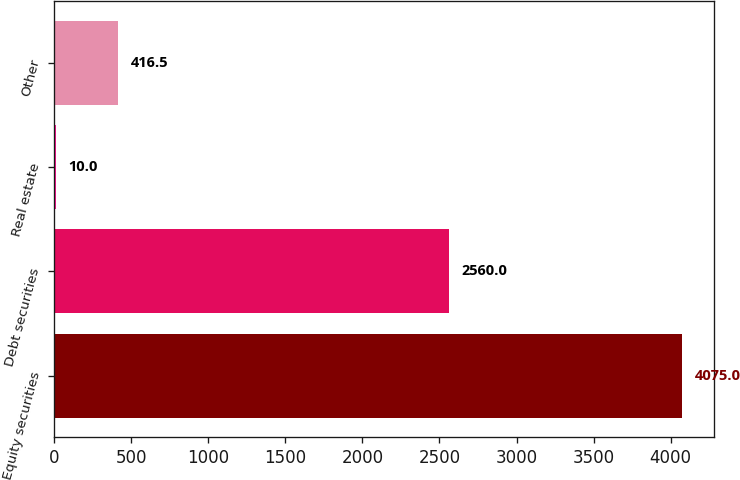Convert chart to OTSL. <chart><loc_0><loc_0><loc_500><loc_500><bar_chart><fcel>Equity securities<fcel>Debt securities<fcel>Real estate<fcel>Other<nl><fcel>4075<fcel>2560<fcel>10<fcel>416.5<nl></chart> 